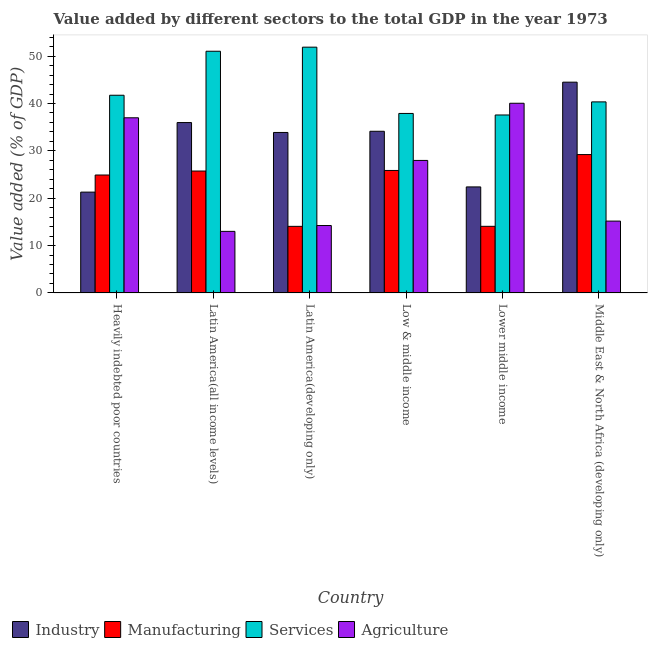How many different coloured bars are there?
Offer a very short reply. 4. Are the number of bars on each tick of the X-axis equal?
Your answer should be compact. Yes. How many bars are there on the 3rd tick from the right?
Make the answer very short. 4. What is the label of the 5th group of bars from the left?
Your answer should be very brief. Lower middle income. In how many cases, is the number of bars for a given country not equal to the number of legend labels?
Provide a succinct answer. 0. What is the value added by services sector in Latin America(all income levels)?
Your answer should be compact. 51.03. Across all countries, what is the maximum value added by agricultural sector?
Your answer should be compact. 40.04. Across all countries, what is the minimum value added by agricultural sector?
Provide a succinct answer. 13. In which country was the value added by agricultural sector maximum?
Make the answer very short. Lower middle income. In which country was the value added by services sector minimum?
Make the answer very short. Lower middle income. What is the total value added by industrial sector in the graph?
Your answer should be very brief. 192.15. What is the difference between the value added by agricultural sector in Low & middle income and that in Lower middle income?
Provide a succinct answer. -12.07. What is the difference between the value added by manufacturing sector in Latin America(all income levels) and the value added by services sector in Latin America(developing only)?
Ensure brevity in your answer.  -26.15. What is the average value added by manufacturing sector per country?
Give a very brief answer. 22.3. What is the difference between the value added by services sector and value added by agricultural sector in Lower middle income?
Give a very brief answer. -2.47. What is the ratio of the value added by manufacturing sector in Low & middle income to that in Middle East & North Africa (developing only)?
Give a very brief answer. 0.89. What is the difference between the highest and the second highest value added by services sector?
Provide a short and direct response. 0.86. What is the difference between the highest and the lowest value added by agricultural sector?
Offer a very short reply. 27.05. In how many countries, is the value added by manufacturing sector greater than the average value added by manufacturing sector taken over all countries?
Offer a very short reply. 4. Is the sum of the value added by services sector in Lower middle income and Middle East & North Africa (developing only) greater than the maximum value added by industrial sector across all countries?
Keep it short and to the point. Yes. Is it the case that in every country, the sum of the value added by manufacturing sector and value added by services sector is greater than the sum of value added by industrial sector and value added by agricultural sector?
Provide a short and direct response. No. What does the 3rd bar from the left in Heavily indebted poor countries represents?
Keep it short and to the point. Services. What does the 2nd bar from the right in Latin America(all income levels) represents?
Your answer should be compact. Services. Is it the case that in every country, the sum of the value added by industrial sector and value added by manufacturing sector is greater than the value added by services sector?
Give a very brief answer. No. Where does the legend appear in the graph?
Your response must be concise. Bottom left. How are the legend labels stacked?
Offer a very short reply. Horizontal. What is the title of the graph?
Give a very brief answer. Value added by different sectors to the total GDP in the year 1973. Does "Fiscal policy" appear as one of the legend labels in the graph?
Provide a succinct answer. No. What is the label or title of the Y-axis?
Your response must be concise. Value added (% of GDP). What is the Value added (% of GDP) of Industry in Heavily indebted poor countries?
Offer a very short reply. 21.29. What is the Value added (% of GDP) in Manufacturing in Heavily indebted poor countries?
Ensure brevity in your answer.  24.9. What is the Value added (% of GDP) of Services in Heavily indebted poor countries?
Make the answer very short. 41.74. What is the Value added (% of GDP) of Agriculture in Heavily indebted poor countries?
Your answer should be very brief. 36.98. What is the Value added (% of GDP) in Industry in Latin America(all income levels)?
Your answer should be very brief. 35.97. What is the Value added (% of GDP) in Manufacturing in Latin America(all income levels)?
Offer a terse response. 25.73. What is the Value added (% of GDP) in Services in Latin America(all income levels)?
Your response must be concise. 51.03. What is the Value added (% of GDP) in Agriculture in Latin America(all income levels)?
Ensure brevity in your answer.  13. What is the Value added (% of GDP) of Industry in Latin America(developing only)?
Offer a very short reply. 33.88. What is the Value added (% of GDP) in Manufacturing in Latin America(developing only)?
Your response must be concise. 14.06. What is the Value added (% of GDP) in Services in Latin America(developing only)?
Your answer should be very brief. 51.89. What is the Value added (% of GDP) of Agriculture in Latin America(developing only)?
Offer a very short reply. 14.23. What is the Value added (% of GDP) in Industry in Low & middle income?
Your answer should be very brief. 34.13. What is the Value added (% of GDP) in Manufacturing in Low & middle income?
Offer a terse response. 25.86. What is the Value added (% of GDP) of Services in Low & middle income?
Your answer should be very brief. 37.89. What is the Value added (% of GDP) in Agriculture in Low & middle income?
Keep it short and to the point. 27.98. What is the Value added (% of GDP) of Industry in Lower middle income?
Provide a short and direct response. 22.39. What is the Value added (% of GDP) in Manufacturing in Lower middle income?
Offer a terse response. 14.06. What is the Value added (% of GDP) in Services in Lower middle income?
Ensure brevity in your answer.  37.57. What is the Value added (% of GDP) of Agriculture in Lower middle income?
Offer a very short reply. 40.04. What is the Value added (% of GDP) in Industry in Middle East & North Africa (developing only)?
Make the answer very short. 44.5. What is the Value added (% of GDP) of Manufacturing in Middle East & North Africa (developing only)?
Your answer should be compact. 29.21. What is the Value added (% of GDP) in Services in Middle East & North Africa (developing only)?
Ensure brevity in your answer.  40.34. What is the Value added (% of GDP) in Agriculture in Middle East & North Africa (developing only)?
Give a very brief answer. 15.17. Across all countries, what is the maximum Value added (% of GDP) in Industry?
Provide a succinct answer. 44.5. Across all countries, what is the maximum Value added (% of GDP) of Manufacturing?
Your response must be concise. 29.21. Across all countries, what is the maximum Value added (% of GDP) of Services?
Your answer should be compact. 51.89. Across all countries, what is the maximum Value added (% of GDP) of Agriculture?
Ensure brevity in your answer.  40.04. Across all countries, what is the minimum Value added (% of GDP) in Industry?
Offer a terse response. 21.29. Across all countries, what is the minimum Value added (% of GDP) in Manufacturing?
Ensure brevity in your answer.  14.06. Across all countries, what is the minimum Value added (% of GDP) of Services?
Give a very brief answer. 37.57. Across all countries, what is the minimum Value added (% of GDP) of Agriculture?
Make the answer very short. 13. What is the total Value added (% of GDP) in Industry in the graph?
Provide a succinct answer. 192.15. What is the total Value added (% of GDP) of Manufacturing in the graph?
Make the answer very short. 133.82. What is the total Value added (% of GDP) in Services in the graph?
Your answer should be very brief. 260.46. What is the total Value added (% of GDP) in Agriculture in the graph?
Provide a short and direct response. 147.4. What is the difference between the Value added (% of GDP) in Industry in Heavily indebted poor countries and that in Latin America(all income levels)?
Ensure brevity in your answer.  -14.69. What is the difference between the Value added (% of GDP) of Manufacturing in Heavily indebted poor countries and that in Latin America(all income levels)?
Provide a succinct answer. -0.84. What is the difference between the Value added (% of GDP) of Services in Heavily indebted poor countries and that in Latin America(all income levels)?
Ensure brevity in your answer.  -9.29. What is the difference between the Value added (% of GDP) of Agriculture in Heavily indebted poor countries and that in Latin America(all income levels)?
Provide a short and direct response. 23.98. What is the difference between the Value added (% of GDP) of Industry in Heavily indebted poor countries and that in Latin America(developing only)?
Offer a very short reply. -12.59. What is the difference between the Value added (% of GDP) in Manufacturing in Heavily indebted poor countries and that in Latin America(developing only)?
Ensure brevity in your answer.  10.84. What is the difference between the Value added (% of GDP) of Services in Heavily indebted poor countries and that in Latin America(developing only)?
Ensure brevity in your answer.  -10.15. What is the difference between the Value added (% of GDP) in Agriculture in Heavily indebted poor countries and that in Latin America(developing only)?
Make the answer very short. 22.75. What is the difference between the Value added (% of GDP) of Industry in Heavily indebted poor countries and that in Low & middle income?
Offer a very short reply. -12.84. What is the difference between the Value added (% of GDP) of Manufacturing in Heavily indebted poor countries and that in Low & middle income?
Provide a succinct answer. -0.96. What is the difference between the Value added (% of GDP) of Services in Heavily indebted poor countries and that in Low & middle income?
Give a very brief answer. 3.84. What is the difference between the Value added (% of GDP) in Agriculture in Heavily indebted poor countries and that in Low & middle income?
Offer a very short reply. 9. What is the difference between the Value added (% of GDP) of Industry in Heavily indebted poor countries and that in Lower middle income?
Keep it short and to the point. -1.1. What is the difference between the Value added (% of GDP) in Manufacturing in Heavily indebted poor countries and that in Lower middle income?
Ensure brevity in your answer.  10.83. What is the difference between the Value added (% of GDP) of Services in Heavily indebted poor countries and that in Lower middle income?
Ensure brevity in your answer.  4.17. What is the difference between the Value added (% of GDP) in Agriculture in Heavily indebted poor countries and that in Lower middle income?
Your response must be concise. -3.07. What is the difference between the Value added (% of GDP) of Industry in Heavily indebted poor countries and that in Middle East & North Africa (developing only)?
Your response must be concise. -23.21. What is the difference between the Value added (% of GDP) in Manufacturing in Heavily indebted poor countries and that in Middle East & North Africa (developing only)?
Your response must be concise. -4.31. What is the difference between the Value added (% of GDP) of Services in Heavily indebted poor countries and that in Middle East & North Africa (developing only)?
Provide a short and direct response. 1.4. What is the difference between the Value added (% of GDP) of Agriculture in Heavily indebted poor countries and that in Middle East & North Africa (developing only)?
Offer a terse response. 21.81. What is the difference between the Value added (% of GDP) of Industry in Latin America(all income levels) and that in Latin America(developing only)?
Give a very brief answer. 2.09. What is the difference between the Value added (% of GDP) in Manufacturing in Latin America(all income levels) and that in Latin America(developing only)?
Ensure brevity in your answer.  11.68. What is the difference between the Value added (% of GDP) in Services in Latin America(all income levels) and that in Latin America(developing only)?
Make the answer very short. -0.86. What is the difference between the Value added (% of GDP) of Agriculture in Latin America(all income levels) and that in Latin America(developing only)?
Provide a succinct answer. -1.23. What is the difference between the Value added (% of GDP) of Industry in Latin America(all income levels) and that in Low & middle income?
Offer a very short reply. 1.84. What is the difference between the Value added (% of GDP) in Manufacturing in Latin America(all income levels) and that in Low & middle income?
Your answer should be compact. -0.12. What is the difference between the Value added (% of GDP) of Services in Latin America(all income levels) and that in Low & middle income?
Provide a succinct answer. 13.13. What is the difference between the Value added (% of GDP) in Agriculture in Latin America(all income levels) and that in Low & middle income?
Provide a succinct answer. -14.98. What is the difference between the Value added (% of GDP) of Industry in Latin America(all income levels) and that in Lower middle income?
Provide a succinct answer. 13.59. What is the difference between the Value added (% of GDP) in Manufacturing in Latin America(all income levels) and that in Lower middle income?
Provide a succinct answer. 11.67. What is the difference between the Value added (% of GDP) of Services in Latin America(all income levels) and that in Lower middle income?
Offer a very short reply. 13.46. What is the difference between the Value added (% of GDP) in Agriculture in Latin America(all income levels) and that in Lower middle income?
Ensure brevity in your answer.  -27.05. What is the difference between the Value added (% of GDP) in Industry in Latin America(all income levels) and that in Middle East & North Africa (developing only)?
Make the answer very short. -8.53. What is the difference between the Value added (% of GDP) of Manufacturing in Latin America(all income levels) and that in Middle East & North Africa (developing only)?
Your answer should be very brief. -3.48. What is the difference between the Value added (% of GDP) of Services in Latin America(all income levels) and that in Middle East & North Africa (developing only)?
Offer a terse response. 10.69. What is the difference between the Value added (% of GDP) in Agriculture in Latin America(all income levels) and that in Middle East & North Africa (developing only)?
Provide a succinct answer. -2.17. What is the difference between the Value added (% of GDP) in Industry in Latin America(developing only) and that in Low & middle income?
Ensure brevity in your answer.  -0.25. What is the difference between the Value added (% of GDP) in Manufacturing in Latin America(developing only) and that in Low & middle income?
Offer a terse response. -11.8. What is the difference between the Value added (% of GDP) in Services in Latin America(developing only) and that in Low & middle income?
Provide a succinct answer. 13.99. What is the difference between the Value added (% of GDP) of Agriculture in Latin America(developing only) and that in Low & middle income?
Offer a terse response. -13.74. What is the difference between the Value added (% of GDP) of Industry in Latin America(developing only) and that in Lower middle income?
Your answer should be very brief. 11.49. What is the difference between the Value added (% of GDP) in Manufacturing in Latin America(developing only) and that in Lower middle income?
Ensure brevity in your answer.  -0.01. What is the difference between the Value added (% of GDP) of Services in Latin America(developing only) and that in Lower middle income?
Offer a terse response. 14.32. What is the difference between the Value added (% of GDP) of Agriculture in Latin America(developing only) and that in Lower middle income?
Ensure brevity in your answer.  -25.81. What is the difference between the Value added (% of GDP) in Industry in Latin America(developing only) and that in Middle East & North Africa (developing only)?
Make the answer very short. -10.62. What is the difference between the Value added (% of GDP) in Manufacturing in Latin America(developing only) and that in Middle East & North Africa (developing only)?
Your response must be concise. -15.15. What is the difference between the Value added (% of GDP) of Services in Latin America(developing only) and that in Middle East & North Africa (developing only)?
Make the answer very short. 11.55. What is the difference between the Value added (% of GDP) in Agriculture in Latin America(developing only) and that in Middle East & North Africa (developing only)?
Your response must be concise. -0.93. What is the difference between the Value added (% of GDP) of Industry in Low & middle income and that in Lower middle income?
Your answer should be very brief. 11.74. What is the difference between the Value added (% of GDP) in Manufacturing in Low & middle income and that in Lower middle income?
Offer a terse response. 11.79. What is the difference between the Value added (% of GDP) of Services in Low & middle income and that in Lower middle income?
Make the answer very short. 0.32. What is the difference between the Value added (% of GDP) of Agriculture in Low & middle income and that in Lower middle income?
Ensure brevity in your answer.  -12.07. What is the difference between the Value added (% of GDP) of Industry in Low & middle income and that in Middle East & North Africa (developing only)?
Your response must be concise. -10.37. What is the difference between the Value added (% of GDP) in Manufacturing in Low & middle income and that in Middle East & North Africa (developing only)?
Provide a succinct answer. -3.35. What is the difference between the Value added (% of GDP) of Services in Low & middle income and that in Middle East & North Africa (developing only)?
Give a very brief answer. -2.44. What is the difference between the Value added (% of GDP) of Agriculture in Low & middle income and that in Middle East & North Africa (developing only)?
Ensure brevity in your answer.  12.81. What is the difference between the Value added (% of GDP) in Industry in Lower middle income and that in Middle East & North Africa (developing only)?
Ensure brevity in your answer.  -22.11. What is the difference between the Value added (% of GDP) of Manufacturing in Lower middle income and that in Middle East & North Africa (developing only)?
Offer a terse response. -15.15. What is the difference between the Value added (% of GDP) of Services in Lower middle income and that in Middle East & North Africa (developing only)?
Give a very brief answer. -2.77. What is the difference between the Value added (% of GDP) of Agriculture in Lower middle income and that in Middle East & North Africa (developing only)?
Give a very brief answer. 24.88. What is the difference between the Value added (% of GDP) of Industry in Heavily indebted poor countries and the Value added (% of GDP) of Manufacturing in Latin America(all income levels)?
Your response must be concise. -4.45. What is the difference between the Value added (% of GDP) of Industry in Heavily indebted poor countries and the Value added (% of GDP) of Services in Latin America(all income levels)?
Keep it short and to the point. -29.74. What is the difference between the Value added (% of GDP) of Industry in Heavily indebted poor countries and the Value added (% of GDP) of Agriculture in Latin America(all income levels)?
Make the answer very short. 8.29. What is the difference between the Value added (% of GDP) in Manufacturing in Heavily indebted poor countries and the Value added (% of GDP) in Services in Latin America(all income levels)?
Make the answer very short. -26.13. What is the difference between the Value added (% of GDP) of Manufacturing in Heavily indebted poor countries and the Value added (% of GDP) of Agriculture in Latin America(all income levels)?
Give a very brief answer. 11.9. What is the difference between the Value added (% of GDP) in Services in Heavily indebted poor countries and the Value added (% of GDP) in Agriculture in Latin America(all income levels)?
Offer a terse response. 28.74. What is the difference between the Value added (% of GDP) in Industry in Heavily indebted poor countries and the Value added (% of GDP) in Manufacturing in Latin America(developing only)?
Offer a very short reply. 7.23. What is the difference between the Value added (% of GDP) in Industry in Heavily indebted poor countries and the Value added (% of GDP) in Services in Latin America(developing only)?
Provide a succinct answer. -30.6. What is the difference between the Value added (% of GDP) of Industry in Heavily indebted poor countries and the Value added (% of GDP) of Agriculture in Latin America(developing only)?
Give a very brief answer. 7.05. What is the difference between the Value added (% of GDP) in Manufacturing in Heavily indebted poor countries and the Value added (% of GDP) in Services in Latin America(developing only)?
Offer a very short reply. -26.99. What is the difference between the Value added (% of GDP) of Manufacturing in Heavily indebted poor countries and the Value added (% of GDP) of Agriculture in Latin America(developing only)?
Your answer should be compact. 10.66. What is the difference between the Value added (% of GDP) of Services in Heavily indebted poor countries and the Value added (% of GDP) of Agriculture in Latin America(developing only)?
Offer a very short reply. 27.51. What is the difference between the Value added (% of GDP) of Industry in Heavily indebted poor countries and the Value added (% of GDP) of Manufacturing in Low & middle income?
Provide a short and direct response. -4.57. What is the difference between the Value added (% of GDP) of Industry in Heavily indebted poor countries and the Value added (% of GDP) of Services in Low & middle income?
Your answer should be compact. -16.61. What is the difference between the Value added (% of GDP) of Industry in Heavily indebted poor countries and the Value added (% of GDP) of Agriculture in Low & middle income?
Make the answer very short. -6.69. What is the difference between the Value added (% of GDP) of Manufacturing in Heavily indebted poor countries and the Value added (% of GDP) of Services in Low & middle income?
Your response must be concise. -13. What is the difference between the Value added (% of GDP) of Manufacturing in Heavily indebted poor countries and the Value added (% of GDP) of Agriculture in Low & middle income?
Ensure brevity in your answer.  -3.08. What is the difference between the Value added (% of GDP) in Services in Heavily indebted poor countries and the Value added (% of GDP) in Agriculture in Low & middle income?
Provide a succinct answer. 13.76. What is the difference between the Value added (% of GDP) in Industry in Heavily indebted poor countries and the Value added (% of GDP) in Manufacturing in Lower middle income?
Your answer should be compact. 7.22. What is the difference between the Value added (% of GDP) in Industry in Heavily indebted poor countries and the Value added (% of GDP) in Services in Lower middle income?
Provide a succinct answer. -16.28. What is the difference between the Value added (% of GDP) of Industry in Heavily indebted poor countries and the Value added (% of GDP) of Agriculture in Lower middle income?
Your answer should be very brief. -18.76. What is the difference between the Value added (% of GDP) of Manufacturing in Heavily indebted poor countries and the Value added (% of GDP) of Services in Lower middle income?
Your answer should be very brief. -12.67. What is the difference between the Value added (% of GDP) of Manufacturing in Heavily indebted poor countries and the Value added (% of GDP) of Agriculture in Lower middle income?
Provide a short and direct response. -15.15. What is the difference between the Value added (% of GDP) in Services in Heavily indebted poor countries and the Value added (% of GDP) in Agriculture in Lower middle income?
Ensure brevity in your answer.  1.69. What is the difference between the Value added (% of GDP) of Industry in Heavily indebted poor countries and the Value added (% of GDP) of Manufacturing in Middle East & North Africa (developing only)?
Provide a short and direct response. -7.93. What is the difference between the Value added (% of GDP) of Industry in Heavily indebted poor countries and the Value added (% of GDP) of Services in Middle East & North Africa (developing only)?
Your answer should be compact. -19.05. What is the difference between the Value added (% of GDP) in Industry in Heavily indebted poor countries and the Value added (% of GDP) in Agriculture in Middle East & North Africa (developing only)?
Offer a very short reply. 6.12. What is the difference between the Value added (% of GDP) in Manufacturing in Heavily indebted poor countries and the Value added (% of GDP) in Services in Middle East & North Africa (developing only)?
Offer a terse response. -15.44. What is the difference between the Value added (% of GDP) of Manufacturing in Heavily indebted poor countries and the Value added (% of GDP) of Agriculture in Middle East & North Africa (developing only)?
Your answer should be very brief. 9.73. What is the difference between the Value added (% of GDP) in Services in Heavily indebted poor countries and the Value added (% of GDP) in Agriculture in Middle East & North Africa (developing only)?
Your answer should be compact. 26.57. What is the difference between the Value added (% of GDP) in Industry in Latin America(all income levels) and the Value added (% of GDP) in Manufacturing in Latin America(developing only)?
Give a very brief answer. 21.91. What is the difference between the Value added (% of GDP) of Industry in Latin America(all income levels) and the Value added (% of GDP) of Services in Latin America(developing only)?
Provide a short and direct response. -15.92. What is the difference between the Value added (% of GDP) of Industry in Latin America(all income levels) and the Value added (% of GDP) of Agriculture in Latin America(developing only)?
Offer a very short reply. 21.74. What is the difference between the Value added (% of GDP) in Manufacturing in Latin America(all income levels) and the Value added (% of GDP) in Services in Latin America(developing only)?
Provide a succinct answer. -26.15. What is the difference between the Value added (% of GDP) in Manufacturing in Latin America(all income levels) and the Value added (% of GDP) in Agriculture in Latin America(developing only)?
Provide a succinct answer. 11.5. What is the difference between the Value added (% of GDP) in Services in Latin America(all income levels) and the Value added (% of GDP) in Agriculture in Latin America(developing only)?
Provide a short and direct response. 36.8. What is the difference between the Value added (% of GDP) in Industry in Latin America(all income levels) and the Value added (% of GDP) in Manufacturing in Low & middle income?
Offer a very short reply. 10.11. What is the difference between the Value added (% of GDP) in Industry in Latin America(all income levels) and the Value added (% of GDP) in Services in Low & middle income?
Offer a terse response. -1.92. What is the difference between the Value added (% of GDP) in Industry in Latin America(all income levels) and the Value added (% of GDP) in Agriculture in Low & middle income?
Provide a succinct answer. 8. What is the difference between the Value added (% of GDP) in Manufacturing in Latin America(all income levels) and the Value added (% of GDP) in Services in Low & middle income?
Provide a succinct answer. -12.16. What is the difference between the Value added (% of GDP) in Manufacturing in Latin America(all income levels) and the Value added (% of GDP) in Agriculture in Low & middle income?
Provide a short and direct response. -2.24. What is the difference between the Value added (% of GDP) of Services in Latin America(all income levels) and the Value added (% of GDP) of Agriculture in Low & middle income?
Make the answer very short. 23.05. What is the difference between the Value added (% of GDP) in Industry in Latin America(all income levels) and the Value added (% of GDP) in Manufacturing in Lower middle income?
Your answer should be compact. 21.91. What is the difference between the Value added (% of GDP) in Industry in Latin America(all income levels) and the Value added (% of GDP) in Services in Lower middle income?
Provide a succinct answer. -1.6. What is the difference between the Value added (% of GDP) in Industry in Latin America(all income levels) and the Value added (% of GDP) in Agriculture in Lower middle income?
Provide a succinct answer. -4.07. What is the difference between the Value added (% of GDP) in Manufacturing in Latin America(all income levels) and the Value added (% of GDP) in Services in Lower middle income?
Ensure brevity in your answer.  -11.84. What is the difference between the Value added (% of GDP) of Manufacturing in Latin America(all income levels) and the Value added (% of GDP) of Agriculture in Lower middle income?
Your response must be concise. -14.31. What is the difference between the Value added (% of GDP) in Services in Latin America(all income levels) and the Value added (% of GDP) in Agriculture in Lower middle income?
Your answer should be compact. 10.98. What is the difference between the Value added (% of GDP) in Industry in Latin America(all income levels) and the Value added (% of GDP) in Manufacturing in Middle East & North Africa (developing only)?
Keep it short and to the point. 6.76. What is the difference between the Value added (% of GDP) of Industry in Latin America(all income levels) and the Value added (% of GDP) of Services in Middle East & North Africa (developing only)?
Your answer should be compact. -4.36. What is the difference between the Value added (% of GDP) of Industry in Latin America(all income levels) and the Value added (% of GDP) of Agriculture in Middle East & North Africa (developing only)?
Provide a succinct answer. 20.81. What is the difference between the Value added (% of GDP) of Manufacturing in Latin America(all income levels) and the Value added (% of GDP) of Services in Middle East & North Africa (developing only)?
Your answer should be very brief. -14.6. What is the difference between the Value added (% of GDP) of Manufacturing in Latin America(all income levels) and the Value added (% of GDP) of Agriculture in Middle East & North Africa (developing only)?
Your answer should be compact. 10.57. What is the difference between the Value added (% of GDP) in Services in Latin America(all income levels) and the Value added (% of GDP) in Agriculture in Middle East & North Africa (developing only)?
Your answer should be very brief. 35.86. What is the difference between the Value added (% of GDP) of Industry in Latin America(developing only) and the Value added (% of GDP) of Manufacturing in Low & middle income?
Make the answer very short. 8.02. What is the difference between the Value added (% of GDP) of Industry in Latin America(developing only) and the Value added (% of GDP) of Services in Low & middle income?
Offer a terse response. -4.02. What is the difference between the Value added (% of GDP) in Industry in Latin America(developing only) and the Value added (% of GDP) in Agriculture in Low & middle income?
Provide a succinct answer. 5.9. What is the difference between the Value added (% of GDP) of Manufacturing in Latin America(developing only) and the Value added (% of GDP) of Services in Low & middle income?
Provide a short and direct response. -23.84. What is the difference between the Value added (% of GDP) in Manufacturing in Latin America(developing only) and the Value added (% of GDP) in Agriculture in Low & middle income?
Your answer should be compact. -13.92. What is the difference between the Value added (% of GDP) in Services in Latin America(developing only) and the Value added (% of GDP) in Agriculture in Low & middle income?
Keep it short and to the point. 23.91. What is the difference between the Value added (% of GDP) in Industry in Latin America(developing only) and the Value added (% of GDP) in Manufacturing in Lower middle income?
Offer a very short reply. 19.82. What is the difference between the Value added (% of GDP) of Industry in Latin America(developing only) and the Value added (% of GDP) of Services in Lower middle income?
Keep it short and to the point. -3.69. What is the difference between the Value added (% of GDP) of Industry in Latin America(developing only) and the Value added (% of GDP) of Agriculture in Lower middle income?
Provide a succinct answer. -6.17. What is the difference between the Value added (% of GDP) of Manufacturing in Latin America(developing only) and the Value added (% of GDP) of Services in Lower middle income?
Give a very brief answer. -23.51. What is the difference between the Value added (% of GDP) of Manufacturing in Latin America(developing only) and the Value added (% of GDP) of Agriculture in Lower middle income?
Make the answer very short. -25.99. What is the difference between the Value added (% of GDP) of Services in Latin America(developing only) and the Value added (% of GDP) of Agriculture in Lower middle income?
Provide a succinct answer. 11.84. What is the difference between the Value added (% of GDP) of Industry in Latin America(developing only) and the Value added (% of GDP) of Manufacturing in Middle East & North Africa (developing only)?
Provide a short and direct response. 4.67. What is the difference between the Value added (% of GDP) of Industry in Latin America(developing only) and the Value added (% of GDP) of Services in Middle East & North Africa (developing only)?
Provide a short and direct response. -6.46. What is the difference between the Value added (% of GDP) of Industry in Latin America(developing only) and the Value added (% of GDP) of Agriculture in Middle East & North Africa (developing only)?
Provide a succinct answer. 18.71. What is the difference between the Value added (% of GDP) in Manufacturing in Latin America(developing only) and the Value added (% of GDP) in Services in Middle East & North Africa (developing only)?
Your response must be concise. -26.28. What is the difference between the Value added (% of GDP) of Manufacturing in Latin America(developing only) and the Value added (% of GDP) of Agriculture in Middle East & North Africa (developing only)?
Ensure brevity in your answer.  -1.11. What is the difference between the Value added (% of GDP) in Services in Latin America(developing only) and the Value added (% of GDP) in Agriculture in Middle East & North Africa (developing only)?
Your answer should be very brief. 36.72. What is the difference between the Value added (% of GDP) in Industry in Low & middle income and the Value added (% of GDP) in Manufacturing in Lower middle income?
Make the answer very short. 20.07. What is the difference between the Value added (% of GDP) of Industry in Low & middle income and the Value added (% of GDP) of Services in Lower middle income?
Make the answer very short. -3.44. What is the difference between the Value added (% of GDP) in Industry in Low & middle income and the Value added (% of GDP) in Agriculture in Lower middle income?
Your answer should be compact. -5.91. What is the difference between the Value added (% of GDP) of Manufacturing in Low & middle income and the Value added (% of GDP) of Services in Lower middle income?
Make the answer very short. -11.71. What is the difference between the Value added (% of GDP) in Manufacturing in Low & middle income and the Value added (% of GDP) in Agriculture in Lower middle income?
Offer a very short reply. -14.19. What is the difference between the Value added (% of GDP) of Services in Low & middle income and the Value added (% of GDP) of Agriculture in Lower middle income?
Give a very brief answer. -2.15. What is the difference between the Value added (% of GDP) in Industry in Low & middle income and the Value added (% of GDP) in Manufacturing in Middle East & North Africa (developing only)?
Make the answer very short. 4.92. What is the difference between the Value added (% of GDP) of Industry in Low & middle income and the Value added (% of GDP) of Services in Middle East & North Africa (developing only)?
Make the answer very short. -6.21. What is the difference between the Value added (% of GDP) in Industry in Low & middle income and the Value added (% of GDP) in Agriculture in Middle East & North Africa (developing only)?
Offer a very short reply. 18.96. What is the difference between the Value added (% of GDP) of Manufacturing in Low & middle income and the Value added (% of GDP) of Services in Middle East & North Africa (developing only)?
Offer a very short reply. -14.48. What is the difference between the Value added (% of GDP) of Manufacturing in Low & middle income and the Value added (% of GDP) of Agriculture in Middle East & North Africa (developing only)?
Provide a short and direct response. 10.69. What is the difference between the Value added (% of GDP) of Services in Low & middle income and the Value added (% of GDP) of Agriculture in Middle East & North Africa (developing only)?
Offer a terse response. 22.73. What is the difference between the Value added (% of GDP) of Industry in Lower middle income and the Value added (% of GDP) of Manufacturing in Middle East & North Africa (developing only)?
Provide a short and direct response. -6.83. What is the difference between the Value added (% of GDP) in Industry in Lower middle income and the Value added (% of GDP) in Services in Middle East & North Africa (developing only)?
Your response must be concise. -17.95. What is the difference between the Value added (% of GDP) in Industry in Lower middle income and the Value added (% of GDP) in Agriculture in Middle East & North Africa (developing only)?
Make the answer very short. 7.22. What is the difference between the Value added (% of GDP) of Manufacturing in Lower middle income and the Value added (% of GDP) of Services in Middle East & North Africa (developing only)?
Ensure brevity in your answer.  -26.27. What is the difference between the Value added (% of GDP) of Manufacturing in Lower middle income and the Value added (% of GDP) of Agriculture in Middle East & North Africa (developing only)?
Make the answer very short. -1.1. What is the difference between the Value added (% of GDP) of Services in Lower middle income and the Value added (% of GDP) of Agriculture in Middle East & North Africa (developing only)?
Provide a short and direct response. 22.41. What is the average Value added (% of GDP) of Industry per country?
Provide a succinct answer. 32.03. What is the average Value added (% of GDP) of Manufacturing per country?
Ensure brevity in your answer.  22.3. What is the average Value added (% of GDP) of Services per country?
Offer a terse response. 43.41. What is the average Value added (% of GDP) of Agriculture per country?
Provide a succinct answer. 24.57. What is the difference between the Value added (% of GDP) in Industry and Value added (% of GDP) in Manufacturing in Heavily indebted poor countries?
Ensure brevity in your answer.  -3.61. What is the difference between the Value added (% of GDP) in Industry and Value added (% of GDP) in Services in Heavily indebted poor countries?
Offer a very short reply. -20.45. What is the difference between the Value added (% of GDP) of Industry and Value added (% of GDP) of Agriculture in Heavily indebted poor countries?
Your response must be concise. -15.69. What is the difference between the Value added (% of GDP) in Manufacturing and Value added (% of GDP) in Services in Heavily indebted poor countries?
Provide a succinct answer. -16.84. What is the difference between the Value added (% of GDP) of Manufacturing and Value added (% of GDP) of Agriculture in Heavily indebted poor countries?
Your answer should be very brief. -12.08. What is the difference between the Value added (% of GDP) in Services and Value added (% of GDP) in Agriculture in Heavily indebted poor countries?
Your answer should be very brief. 4.76. What is the difference between the Value added (% of GDP) of Industry and Value added (% of GDP) of Manufacturing in Latin America(all income levels)?
Offer a terse response. 10.24. What is the difference between the Value added (% of GDP) in Industry and Value added (% of GDP) in Services in Latin America(all income levels)?
Your answer should be very brief. -15.06. What is the difference between the Value added (% of GDP) of Industry and Value added (% of GDP) of Agriculture in Latin America(all income levels)?
Your answer should be compact. 22.97. What is the difference between the Value added (% of GDP) in Manufacturing and Value added (% of GDP) in Services in Latin America(all income levels)?
Give a very brief answer. -25.29. What is the difference between the Value added (% of GDP) in Manufacturing and Value added (% of GDP) in Agriculture in Latin America(all income levels)?
Provide a short and direct response. 12.74. What is the difference between the Value added (% of GDP) of Services and Value added (% of GDP) of Agriculture in Latin America(all income levels)?
Keep it short and to the point. 38.03. What is the difference between the Value added (% of GDP) in Industry and Value added (% of GDP) in Manufacturing in Latin America(developing only)?
Ensure brevity in your answer.  19.82. What is the difference between the Value added (% of GDP) of Industry and Value added (% of GDP) of Services in Latin America(developing only)?
Provide a succinct answer. -18.01. What is the difference between the Value added (% of GDP) in Industry and Value added (% of GDP) in Agriculture in Latin America(developing only)?
Make the answer very short. 19.65. What is the difference between the Value added (% of GDP) of Manufacturing and Value added (% of GDP) of Services in Latin America(developing only)?
Ensure brevity in your answer.  -37.83. What is the difference between the Value added (% of GDP) of Manufacturing and Value added (% of GDP) of Agriculture in Latin America(developing only)?
Your answer should be compact. -0.17. What is the difference between the Value added (% of GDP) in Services and Value added (% of GDP) in Agriculture in Latin America(developing only)?
Offer a very short reply. 37.66. What is the difference between the Value added (% of GDP) of Industry and Value added (% of GDP) of Manufacturing in Low & middle income?
Your answer should be very brief. 8.27. What is the difference between the Value added (% of GDP) in Industry and Value added (% of GDP) in Services in Low & middle income?
Provide a short and direct response. -3.76. What is the difference between the Value added (% of GDP) of Industry and Value added (% of GDP) of Agriculture in Low & middle income?
Make the answer very short. 6.15. What is the difference between the Value added (% of GDP) of Manufacturing and Value added (% of GDP) of Services in Low & middle income?
Your response must be concise. -12.04. What is the difference between the Value added (% of GDP) of Manufacturing and Value added (% of GDP) of Agriculture in Low & middle income?
Ensure brevity in your answer.  -2.12. What is the difference between the Value added (% of GDP) of Services and Value added (% of GDP) of Agriculture in Low & middle income?
Offer a very short reply. 9.92. What is the difference between the Value added (% of GDP) in Industry and Value added (% of GDP) in Manufacturing in Lower middle income?
Keep it short and to the point. 8.32. What is the difference between the Value added (% of GDP) of Industry and Value added (% of GDP) of Services in Lower middle income?
Make the answer very short. -15.19. What is the difference between the Value added (% of GDP) in Industry and Value added (% of GDP) in Agriculture in Lower middle income?
Provide a short and direct response. -17.66. What is the difference between the Value added (% of GDP) of Manufacturing and Value added (% of GDP) of Services in Lower middle income?
Keep it short and to the point. -23.51. What is the difference between the Value added (% of GDP) of Manufacturing and Value added (% of GDP) of Agriculture in Lower middle income?
Ensure brevity in your answer.  -25.98. What is the difference between the Value added (% of GDP) of Services and Value added (% of GDP) of Agriculture in Lower middle income?
Your response must be concise. -2.47. What is the difference between the Value added (% of GDP) of Industry and Value added (% of GDP) of Manufacturing in Middle East & North Africa (developing only)?
Make the answer very short. 15.29. What is the difference between the Value added (% of GDP) of Industry and Value added (% of GDP) of Services in Middle East & North Africa (developing only)?
Provide a succinct answer. 4.16. What is the difference between the Value added (% of GDP) in Industry and Value added (% of GDP) in Agriculture in Middle East & North Africa (developing only)?
Provide a succinct answer. 29.33. What is the difference between the Value added (% of GDP) in Manufacturing and Value added (% of GDP) in Services in Middle East & North Africa (developing only)?
Your answer should be very brief. -11.13. What is the difference between the Value added (% of GDP) in Manufacturing and Value added (% of GDP) in Agriculture in Middle East & North Africa (developing only)?
Your response must be concise. 14.05. What is the difference between the Value added (% of GDP) of Services and Value added (% of GDP) of Agriculture in Middle East & North Africa (developing only)?
Provide a succinct answer. 25.17. What is the ratio of the Value added (% of GDP) of Industry in Heavily indebted poor countries to that in Latin America(all income levels)?
Offer a very short reply. 0.59. What is the ratio of the Value added (% of GDP) of Manufacturing in Heavily indebted poor countries to that in Latin America(all income levels)?
Ensure brevity in your answer.  0.97. What is the ratio of the Value added (% of GDP) in Services in Heavily indebted poor countries to that in Latin America(all income levels)?
Offer a terse response. 0.82. What is the ratio of the Value added (% of GDP) of Agriculture in Heavily indebted poor countries to that in Latin America(all income levels)?
Give a very brief answer. 2.84. What is the ratio of the Value added (% of GDP) in Industry in Heavily indebted poor countries to that in Latin America(developing only)?
Your response must be concise. 0.63. What is the ratio of the Value added (% of GDP) in Manufacturing in Heavily indebted poor countries to that in Latin America(developing only)?
Offer a very short reply. 1.77. What is the ratio of the Value added (% of GDP) of Services in Heavily indebted poor countries to that in Latin America(developing only)?
Give a very brief answer. 0.8. What is the ratio of the Value added (% of GDP) in Agriculture in Heavily indebted poor countries to that in Latin America(developing only)?
Provide a short and direct response. 2.6. What is the ratio of the Value added (% of GDP) of Industry in Heavily indebted poor countries to that in Low & middle income?
Your response must be concise. 0.62. What is the ratio of the Value added (% of GDP) of Manufacturing in Heavily indebted poor countries to that in Low & middle income?
Provide a succinct answer. 0.96. What is the ratio of the Value added (% of GDP) of Services in Heavily indebted poor countries to that in Low & middle income?
Keep it short and to the point. 1.1. What is the ratio of the Value added (% of GDP) of Agriculture in Heavily indebted poor countries to that in Low & middle income?
Keep it short and to the point. 1.32. What is the ratio of the Value added (% of GDP) of Industry in Heavily indebted poor countries to that in Lower middle income?
Make the answer very short. 0.95. What is the ratio of the Value added (% of GDP) in Manufacturing in Heavily indebted poor countries to that in Lower middle income?
Ensure brevity in your answer.  1.77. What is the ratio of the Value added (% of GDP) in Services in Heavily indebted poor countries to that in Lower middle income?
Your response must be concise. 1.11. What is the ratio of the Value added (% of GDP) in Agriculture in Heavily indebted poor countries to that in Lower middle income?
Provide a succinct answer. 0.92. What is the ratio of the Value added (% of GDP) of Industry in Heavily indebted poor countries to that in Middle East & North Africa (developing only)?
Keep it short and to the point. 0.48. What is the ratio of the Value added (% of GDP) in Manufacturing in Heavily indebted poor countries to that in Middle East & North Africa (developing only)?
Your answer should be very brief. 0.85. What is the ratio of the Value added (% of GDP) in Services in Heavily indebted poor countries to that in Middle East & North Africa (developing only)?
Your answer should be compact. 1.03. What is the ratio of the Value added (% of GDP) in Agriculture in Heavily indebted poor countries to that in Middle East & North Africa (developing only)?
Your answer should be very brief. 2.44. What is the ratio of the Value added (% of GDP) of Industry in Latin America(all income levels) to that in Latin America(developing only)?
Your response must be concise. 1.06. What is the ratio of the Value added (% of GDP) of Manufacturing in Latin America(all income levels) to that in Latin America(developing only)?
Provide a succinct answer. 1.83. What is the ratio of the Value added (% of GDP) in Services in Latin America(all income levels) to that in Latin America(developing only)?
Give a very brief answer. 0.98. What is the ratio of the Value added (% of GDP) of Agriculture in Latin America(all income levels) to that in Latin America(developing only)?
Your answer should be very brief. 0.91. What is the ratio of the Value added (% of GDP) in Industry in Latin America(all income levels) to that in Low & middle income?
Ensure brevity in your answer.  1.05. What is the ratio of the Value added (% of GDP) in Services in Latin America(all income levels) to that in Low & middle income?
Your answer should be compact. 1.35. What is the ratio of the Value added (% of GDP) of Agriculture in Latin America(all income levels) to that in Low & middle income?
Give a very brief answer. 0.46. What is the ratio of the Value added (% of GDP) of Industry in Latin America(all income levels) to that in Lower middle income?
Make the answer very short. 1.61. What is the ratio of the Value added (% of GDP) in Manufacturing in Latin America(all income levels) to that in Lower middle income?
Ensure brevity in your answer.  1.83. What is the ratio of the Value added (% of GDP) in Services in Latin America(all income levels) to that in Lower middle income?
Make the answer very short. 1.36. What is the ratio of the Value added (% of GDP) of Agriculture in Latin America(all income levels) to that in Lower middle income?
Offer a terse response. 0.32. What is the ratio of the Value added (% of GDP) of Industry in Latin America(all income levels) to that in Middle East & North Africa (developing only)?
Make the answer very short. 0.81. What is the ratio of the Value added (% of GDP) in Manufacturing in Latin America(all income levels) to that in Middle East & North Africa (developing only)?
Your response must be concise. 0.88. What is the ratio of the Value added (% of GDP) of Services in Latin America(all income levels) to that in Middle East & North Africa (developing only)?
Provide a succinct answer. 1.27. What is the ratio of the Value added (% of GDP) of Agriculture in Latin America(all income levels) to that in Middle East & North Africa (developing only)?
Your answer should be very brief. 0.86. What is the ratio of the Value added (% of GDP) of Industry in Latin America(developing only) to that in Low & middle income?
Provide a short and direct response. 0.99. What is the ratio of the Value added (% of GDP) in Manufacturing in Latin America(developing only) to that in Low & middle income?
Your response must be concise. 0.54. What is the ratio of the Value added (% of GDP) in Services in Latin America(developing only) to that in Low & middle income?
Your answer should be compact. 1.37. What is the ratio of the Value added (% of GDP) of Agriculture in Latin America(developing only) to that in Low & middle income?
Offer a very short reply. 0.51. What is the ratio of the Value added (% of GDP) in Industry in Latin America(developing only) to that in Lower middle income?
Make the answer very short. 1.51. What is the ratio of the Value added (% of GDP) of Services in Latin America(developing only) to that in Lower middle income?
Offer a terse response. 1.38. What is the ratio of the Value added (% of GDP) in Agriculture in Latin America(developing only) to that in Lower middle income?
Your answer should be compact. 0.36. What is the ratio of the Value added (% of GDP) in Industry in Latin America(developing only) to that in Middle East & North Africa (developing only)?
Provide a short and direct response. 0.76. What is the ratio of the Value added (% of GDP) in Manufacturing in Latin America(developing only) to that in Middle East & North Africa (developing only)?
Make the answer very short. 0.48. What is the ratio of the Value added (% of GDP) in Services in Latin America(developing only) to that in Middle East & North Africa (developing only)?
Offer a terse response. 1.29. What is the ratio of the Value added (% of GDP) of Agriculture in Latin America(developing only) to that in Middle East & North Africa (developing only)?
Ensure brevity in your answer.  0.94. What is the ratio of the Value added (% of GDP) in Industry in Low & middle income to that in Lower middle income?
Ensure brevity in your answer.  1.52. What is the ratio of the Value added (% of GDP) in Manufacturing in Low & middle income to that in Lower middle income?
Give a very brief answer. 1.84. What is the ratio of the Value added (% of GDP) of Services in Low & middle income to that in Lower middle income?
Offer a terse response. 1.01. What is the ratio of the Value added (% of GDP) in Agriculture in Low & middle income to that in Lower middle income?
Give a very brief answer. 0.7. What is the ratio of the Value added (% of GDP) in Industry in Low & middle income to that in Middle East & North Africa (developing only)?
Offer a terse response. 0.77. What is the ratio of the Value added (% of GDP) in Manufacturing in Low & middle income to that in Middle East & North Africa (developing only)?
Provide a succinct answer. 0.89. What is the ratio of the Value added (% of GDP) of Services in Low & middle income to that in Middle East & North Africa (developing only)?
Provide a succinct answer. 0.94. What is the ratio of the Value added (% of GDP) of Agriculture in Low & middle income to that in Middle East & North Africa (developing only)?
Provide a succinct answer. 1.84. What is the ratio of the Value added (% of GDP) of Industry in Lower middle income to that in Middle East & North Africa (developing only)?
Provide a short and direct response. 0.5. What is the ratio of the Value added (% of GDP) of Manufacturing in Lower middle income to that in Middle East & North Africa (developing only)?
Provide a succinct answer. 0.48. What is the ratio of the Value added (% of GDP) in Services in Lower middle income to that in Middle East & North Africa (developing only)?
Provide a short and direct response. 0.93. What is the ratio of the Value added (% of GDP) of Agriculture in Lower middle income to that in Middle East & North Africa (developing only)?
Offer a very short reply. 2.64. What is the difference between the highest and the second highest Value added (% of GDP) of Industry?
Make the answer very short. 8.53. What is the difference between the highest and the second highest Value added (% of GDP) in Manufacturing?
Provide a short and direct response. 3.35. What is the difference between the highest and the second highest Value added (% of GDP) of Services?
Provide a short and direct response. 0.86. What is the difference between the highest and the second highest Value added (% of GDP) in Agriculture?
Offer a very short reply. 3.07. What is the difference between the highest and the lowest Value added (% of GDP) of Industry?
Your response must be concise. 23.21. What is the difference between the highest and the lowest Value added (% of GDP) in Manufacturing?
Your answer should be compact. 15.15. What is the difference between the highest and the lowest Value added (% of GDP) of Services?
Your response must be concise. 14.32. What is the difference between the highest and the lowest Value added (% of GDP) of Agriculture?
Ensure brevity in your answer.  27.05. 